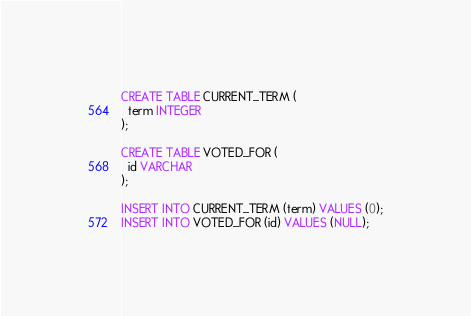<code> <loc_0><loc_0><loc_500><loc_500><_SQL_>CREATE TABLE CURRENT_TERM (
  term INTEGER
);

CREATE TABLE VOTED_FOR (
  id VARCHAR
);

INSERT INTO CURRENT_TERM (term) VALUES (0);
INSERT INTO VOTED_FOR (id) VALUES (NULL);
</code> 